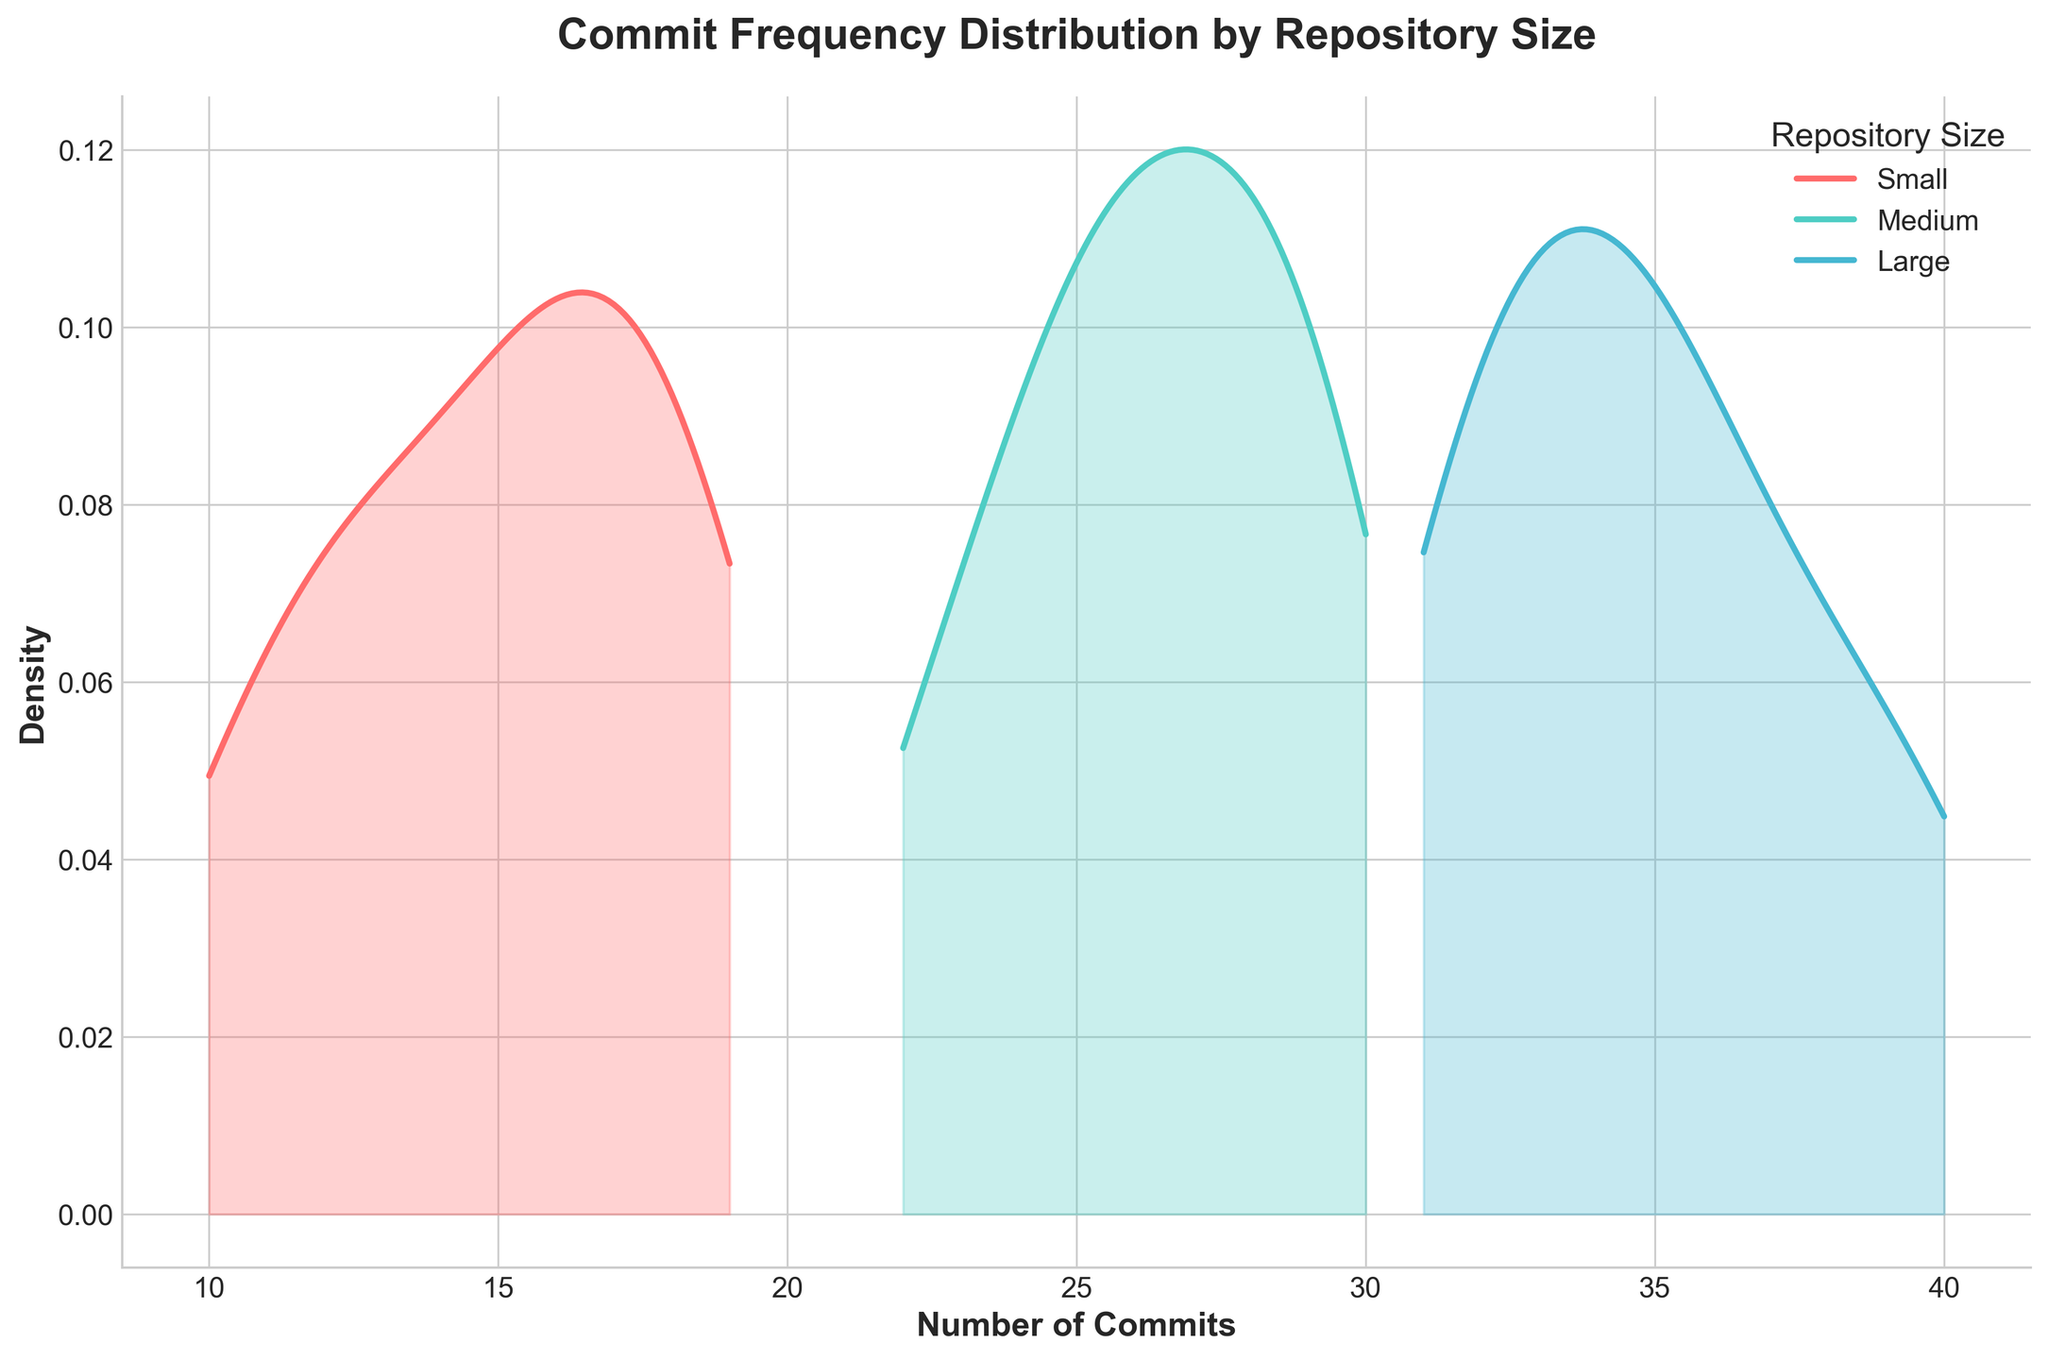What is the title of the figure? The title is displayed at the top of the figure, typically in a larger font size and bolded to grab attention.
Answer: Commit Frequency Distribution by Repository Size What is the x-axis label? The x-axis label is located along the bottom horizontal axis and usually represents the variable being measured along that axis.
Answer: Number of Commits Which repository size appears to have the highest density of commits? By observing the peaks of the density curves, the highest density is where the curve is tallest.
Answer: Large How does the density of commits for small repositories in the range 10-20 compare to that for medium repositories? By comparing the area under the density curves for small and medium repositories between x-values 10 and 20, we see that the curve for small repositories is generally higher.
Answer: Higher for small Which repository size shows the most spread in the number of commits? The spread can be observed by looking at the width of the density curve: the wider the curve, the more spread out the values are.
Answer: Large What is the approximate peak density value for medium repositories? The peak density value corresponds to the highest point of the medium repository density curve (colored in '#4ECDC4').
Answer: Around 0.045 Is the density distribution for small repositories skewed more towards higher or lower commit numbers? By examining the shape of the density curve for small repositories, one can determine the skewness—whether it is leaning more to the left or right.
Answer: Higher commit numbers Do large repositories have a higher density for commits in the range of 30-40 compared to medium repositories? By comparing the height of the density curves for large and medium repositories within the x-value range of 30-40, the taller curve represents higher density.
Answer: Yes How does the peak density value for small repositories compare to that of large repositories? Compare the highest point on the small repository curve to the highest point on the large repository curve.
Answer: Lower Are there any repository sizes that show density distributions with visible bimodal patterns? Bimodal patterns can be identified by looking for density curves with two distinct peaks; check each curve for this characteristic.
Answer: No 